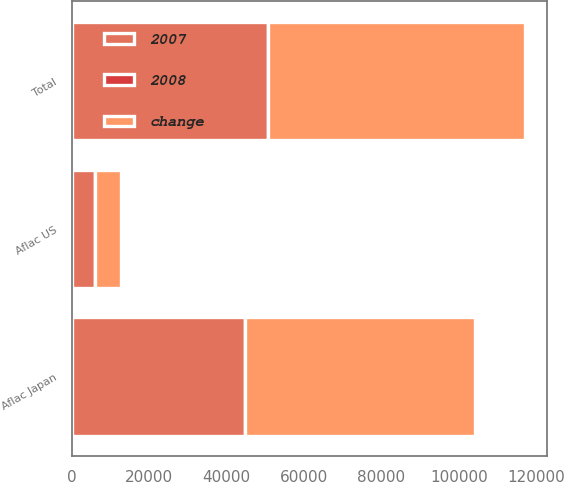Convert chart. <chart><loc_0><loc_0><loc_500><loc_500><stacked_bar_chart><ecel><fcel>Aflac Japan<fcel>Aflac US<fcel>Total<nl><fcel>change<fcel>59466<fcel>6750<fcel>66219<nl><fcel>2007<fcel>44694<fcel>5979<fcel>50676<nl><fcel>2008<fcel>33.1<fcel>12.9<fcel>30.7<nl></chart> 